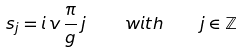Convert formula to latex. <formula><loc_0><loc_0><loc_500><loc_500>s _ { j } = i \, v \, \frac { \pi } { g } \, j \, \quad w i t h \quad j \in { \mathbb { Z } }</formula> 